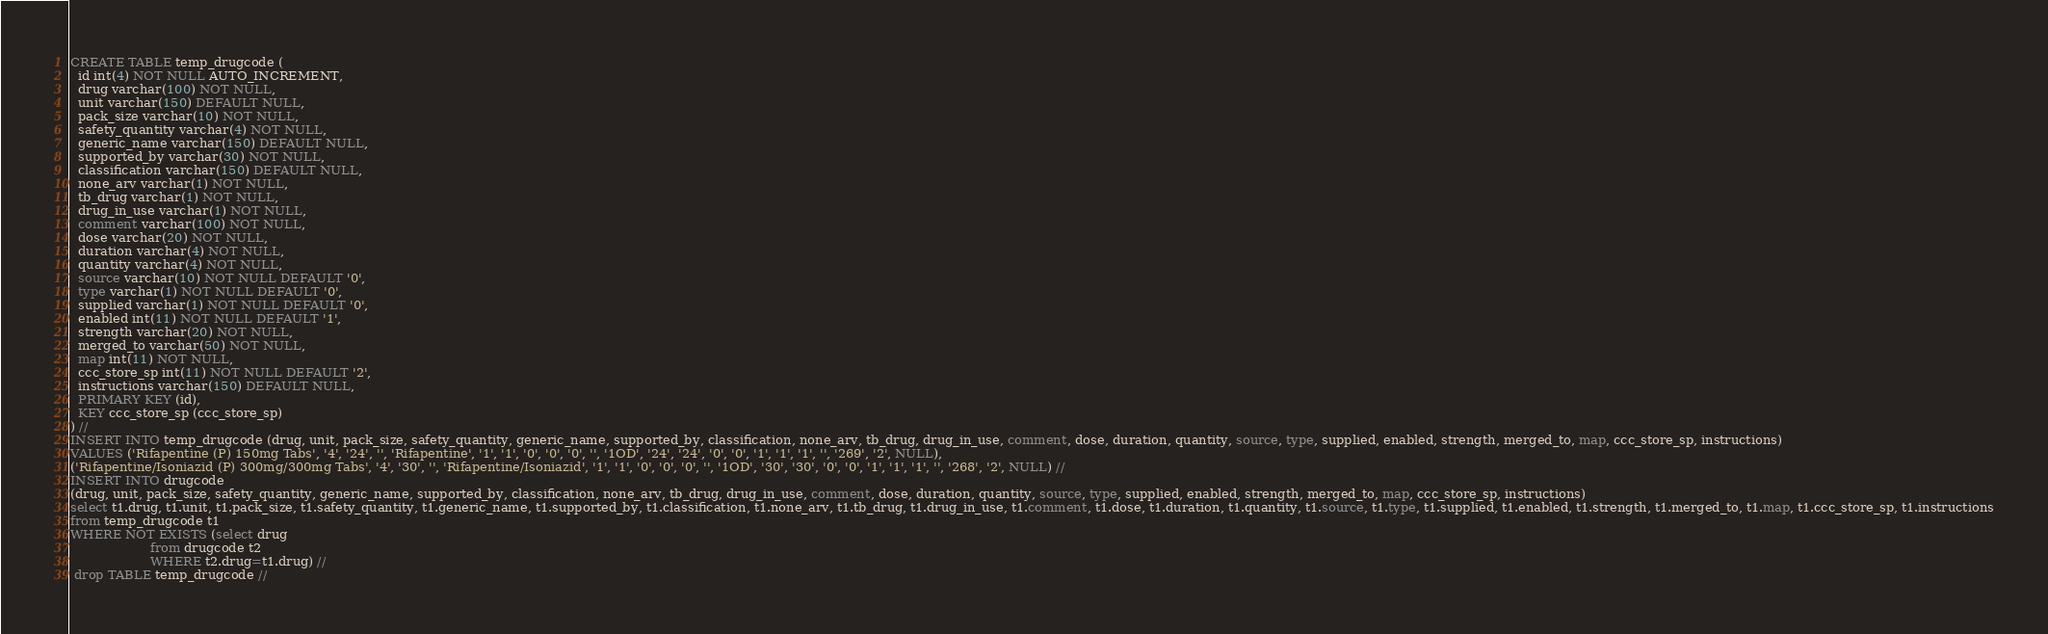<code> <loc_0><loc_0><loc_500><loc_500><_SQL_>CREATE TABLE temp_drugcode (
  id int(4) NOT NULL AUTO_INCREMENT,
  drug varchar(100) NOT NULL,
  unit varchar(150) DEFAULT NULL,
  pack_size varchar(10) NOT NULL,
  safety_quantity varchar(4) NOT NULL,
  generic_name varchar(150) DEFAULT NULL,
  supported_by varchar(30) NOT NULL,
  classification varchar(150) DEFAULT NULL,
  none_arv varchar(1) NOT NULL,
  tb_drug varchar(1) NOT NULL,
  drug_in_use varchar(1) NOT NULL,
  comment varchar(100) NOT NULL,
  dose varchar(20) NOT NULL,
  duration varchar(4) NOT NULL,
  quantity varchar(4) NOT NULL,
  source varchar(10) NOT NULL DEFAULT '0',
  type varchar(1) NOT NULL DEFAULT '0',
  supplied varchar(1) NOT NULL DEFAULT '0',
  enabled int(11) NOT NULL DEFAULT '1',
  strength varchar(20) NOT NULL,
  merged_to varchar(50) NOT NULL,
  map int(11) NOT NULL,
  ccc_store_sp int(11) NOT NULL DEFAULT '2',
  instructions varchar(150) DEFAULT NULL,
  PRIMARY KEY (id),
  KEY ccc_store_sp (ccc_store_sp)
) //
INSERT INTO temp_drugcode (drug, unit, pack_size, safety_quantity, generic_name, supported_by, classification, none_arv, tb_drug, drug_in_use, comment, dose, duration, quantity, source, type, supplied, enabled, strength, merged_to, map, ccc_store_sp, instructions)
VALUES ('Rifapentine (P) 150mg Tabs', '4', '24', '', 'Rifapentine', '1', '1', '0', '0', '0', '', '1OD', '24', '24', '0', '0', '1', '1', '1', '', '269', '2', NULL),
('Rifapentine/Isoniazid (P) 300mg/300mg Tabs', '4', '30', '', 'Rifapentine/Isoniazid', '1', '1', '0', '0', '0', '', '1OD', '30', '30', '0', '0', '1', '1', '1', '', '268', '2', NULL) //
INSERT INTO drugcode 
(drug, unit, pack_size, safety_quantity, generic_name, supported_by, classification, none_arv, tb_drug, drug_in_use, comment, dose, duration, quantity, source, type, supplied, enabled, strength, merged_to, map, ccc_store_sp, instructions)
select t1.drug, t1.unit, t1.pack_size, t1.safety_quantity, t1.generic_name, t1.supported_by, t1.classification, t1.none_arv, t1.tb_drug, t1.drug_in_use, t1.comment, t1.dose, t1.duration, t1.quantity, t1.source, t1.type, t1.supplied, t1.enabled, t1.strength, t1.merged_to, t1.map, t1.ccc_store_sp, t1.instructions
from temp_drugcode t1
WHERE NOT EXISTS (select drug 
                    from drugcode t2
                    WHERE t2.drug=t1.drug) //
 drop TABLE temp_drugcode //</code> 